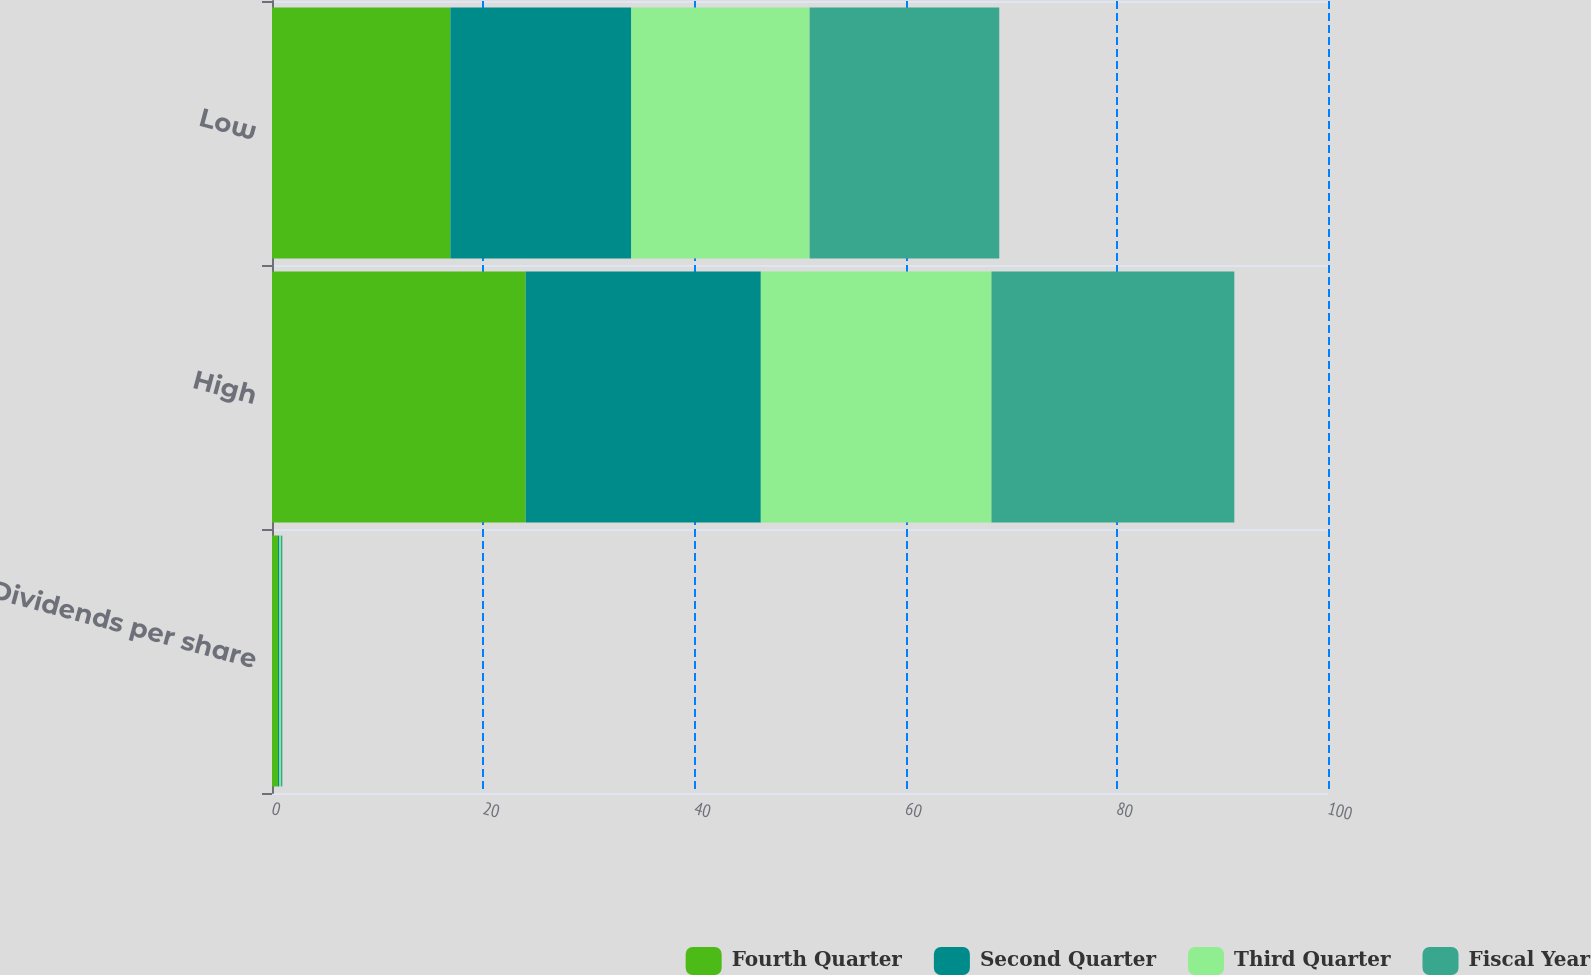Convert chart to OTSL. <chart><loc_0><loc_0><loc_500><loc_500><stacked_bar_chart><ecel><fcel>Dividends per share<fcel>High<fcel>Low<nl><fcel>Fourth Quarter<fcel>0.56<fcel>24.02<fcel>16.89<nl><fcel>Second Quarter<fcel>0.14<fcel>22.27<fcel>17.13<nl><fcel>Third Quarter<fcel>0.14<fcel>21.84<fcel>16.89<nl><fcel>Fiscal Year<fcel>0.14<fcel>23<fcel>17.96<nl></chart> 